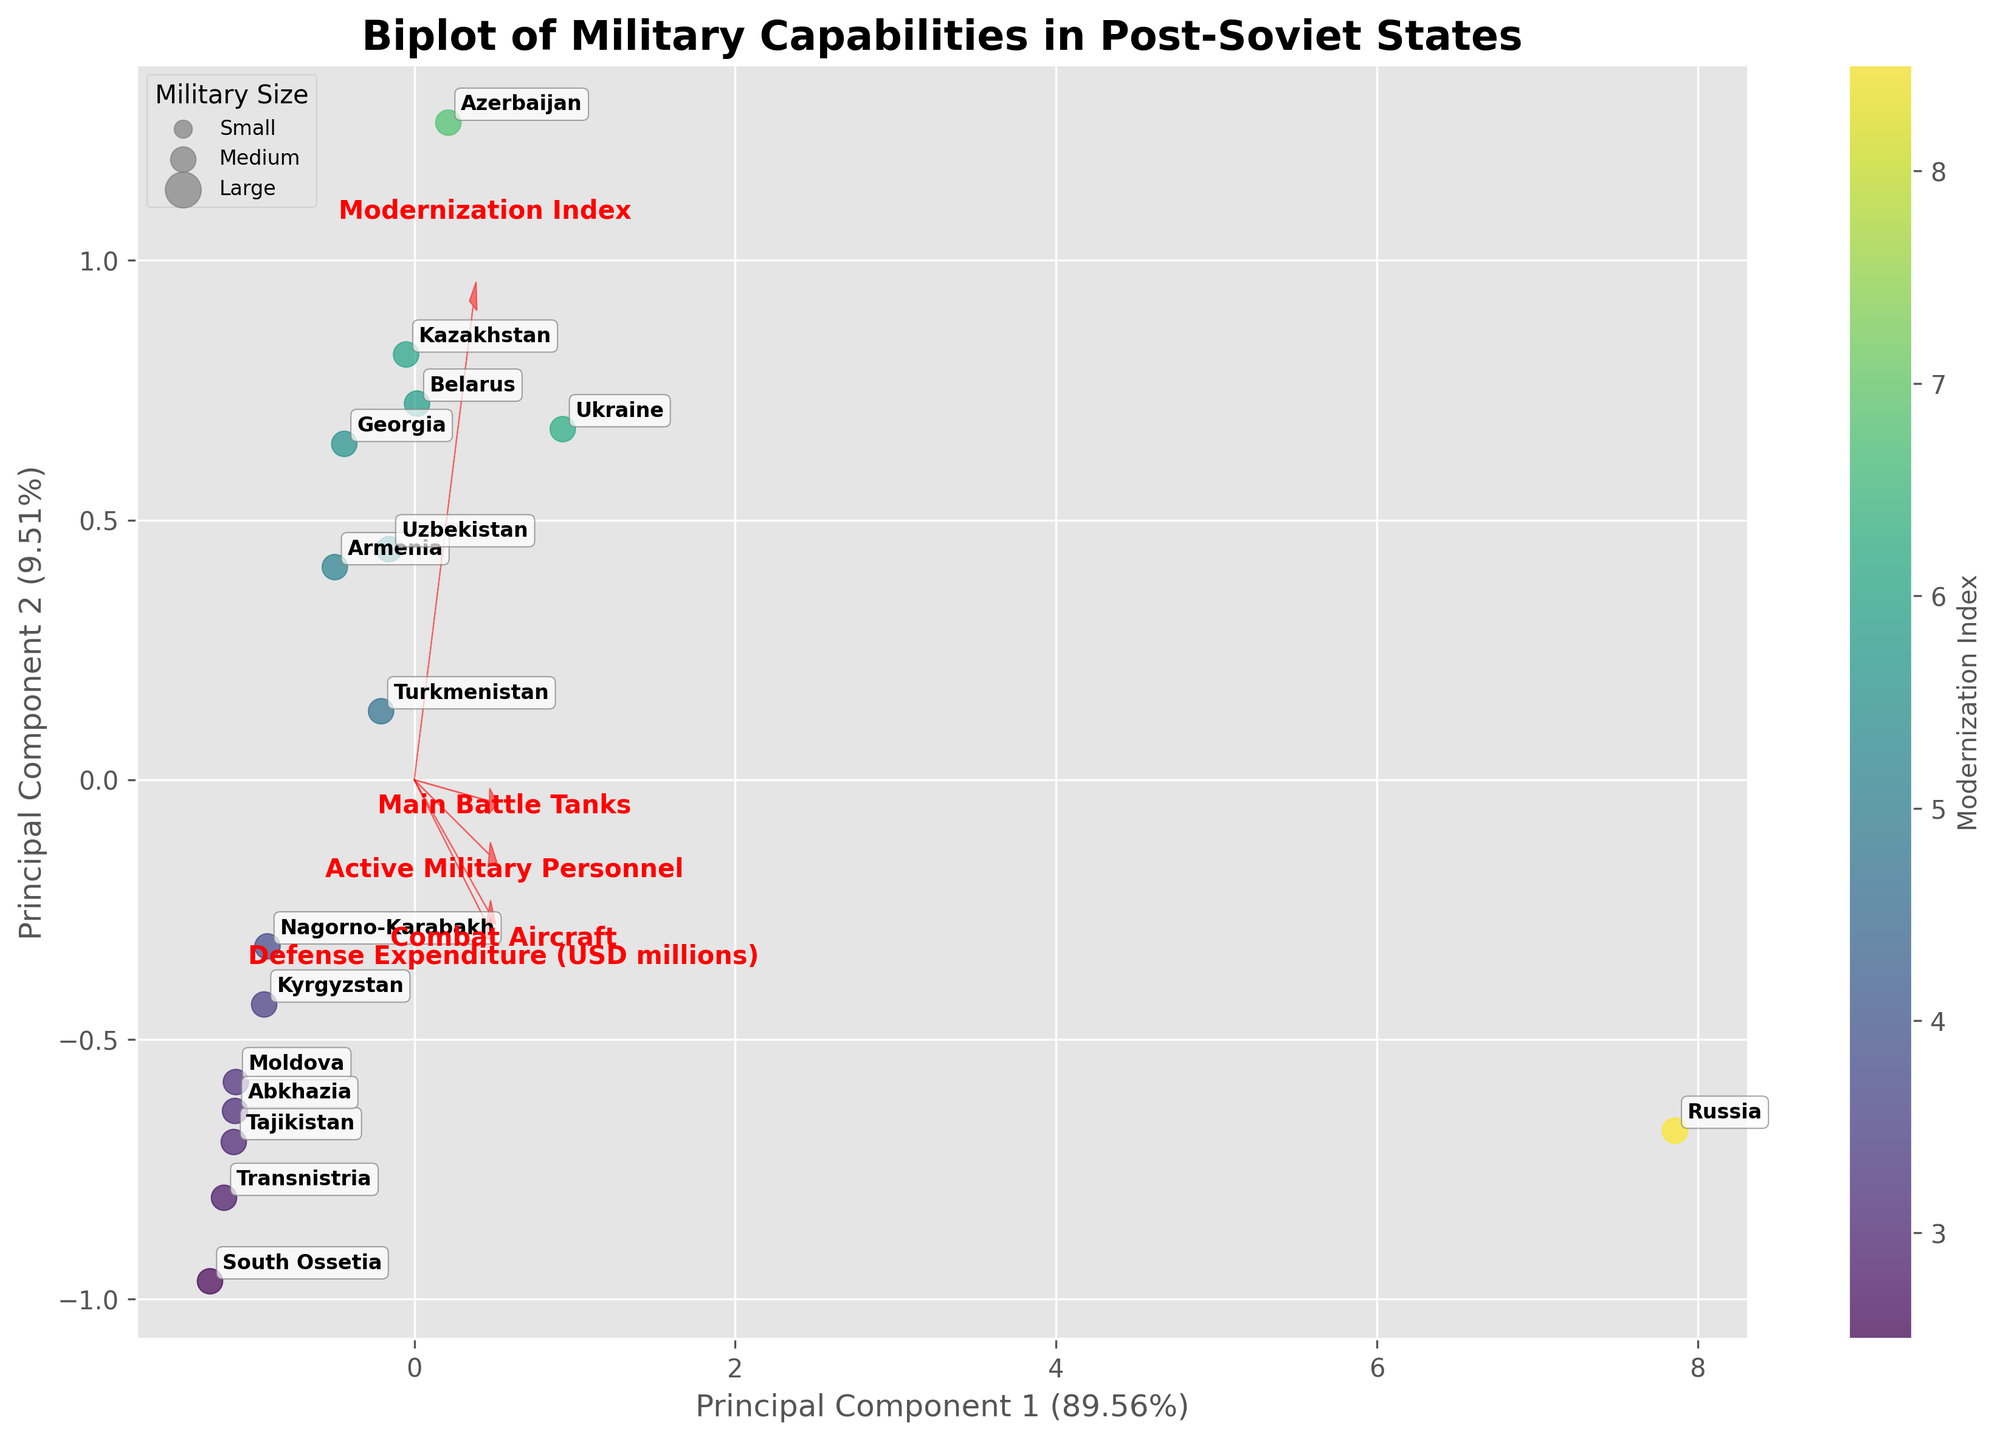What is the title of the figure? The title of the figure is usually located at the top and describes the main theme of the plot. The figure title is "Biplot of Military Capabilities in Post-Soviet States."
Answer: Biplot of Military Capabilities in Post-Soviet States How many recognized and unrecognized post-Soviet states are displayed in the figure? Count the number of country labels in the figure. Each country represents either a recognized or unrecognized post-Soviet state. There are names for both types on the plot. There are 16 countries labeled.
Answer: 16 Which country is situated furthest to the right on the biplot? Look at the farthest point to the right along the principal component 1 (x-axis) and identify the country label positioned there. Russia is furthest to the right.
Answer: Russia Which feature seems to have the greatest impact on principal component 1 (PC1)? Examine the length and direction of the feature vectors (arrows) plotted from the origin (0,0). The feature with the longest arrow along PC1 has the greatest impact. "Defense Expenditure (USD millions)" has the longest arrow in the direction of PC1.
Answer: Defense Expenditure (USD millions) Which two countries have the highest and lowest Modernization Index? Check the color gradient of the scatter points representing each country. The color bar indicates the Modernization Index, with brighter colors showing higher values. Russia shows the highest and South Ossetia shows the lowest Modernization Index values.
Answer: Russia, South Ossetia How is the country with the highest number of Active Military Personnel positioned in the biplot relative to the origin? Identify which country label represents the highest number of Active Military Personnel, then describe its position relative to the plot's origin. Russia has the highest number of Active Military Personnel and it is positioned to the right of the origin.
Answer: To the right What can you infer about the relation between Defense Expenditure and Combat Aircraft based on the feature vectors? Analyze the direction of the arrows representing these features. If the arrows point similarly, the features are positively correlated; if opposite, negatively correlated. Defense Expenditure and Combat Aircraft arrows point in similar directions, indicating a positive correlation.
Answer: Positive correlation Which country is positioned closest to the origin, and what might that imply about its military capabilities? Look for the country label nearest to the origin point (0,0). This usually suggests lower values across most features considered in the analysis. Moldova is closest to the origin, implying it has generally low military capabilities.
Answer: Moldova Comparing Georgia and Kazakhstan, which country has a higher Modernization Index? Referring to the color gradient, find the positions of Georgia and Kazakhstan, and compare their colors. Kazakhstan has a higher Modernization Index, indicated by a brighter color.
Answer: Kazakhstan What does the intersection point of all feature vectors indicate in the biplot? The intersection point (usually around the origin) represents the mean value of all features after standardization. All feature vectors meet approximately at the origin (0,0), indicating it is a reference point for the average standardized features.
Answer: Mean value of features after standardization 